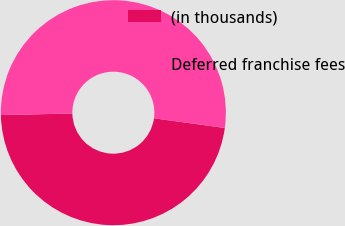<chart> <loc_0><loc_0><loc_500><loc_500><pie_chart><fcel>(in thousands)<fcel>Deferred franchise fees<nl><fcel>47.5%<fcel>52.5%<nl></chart> 